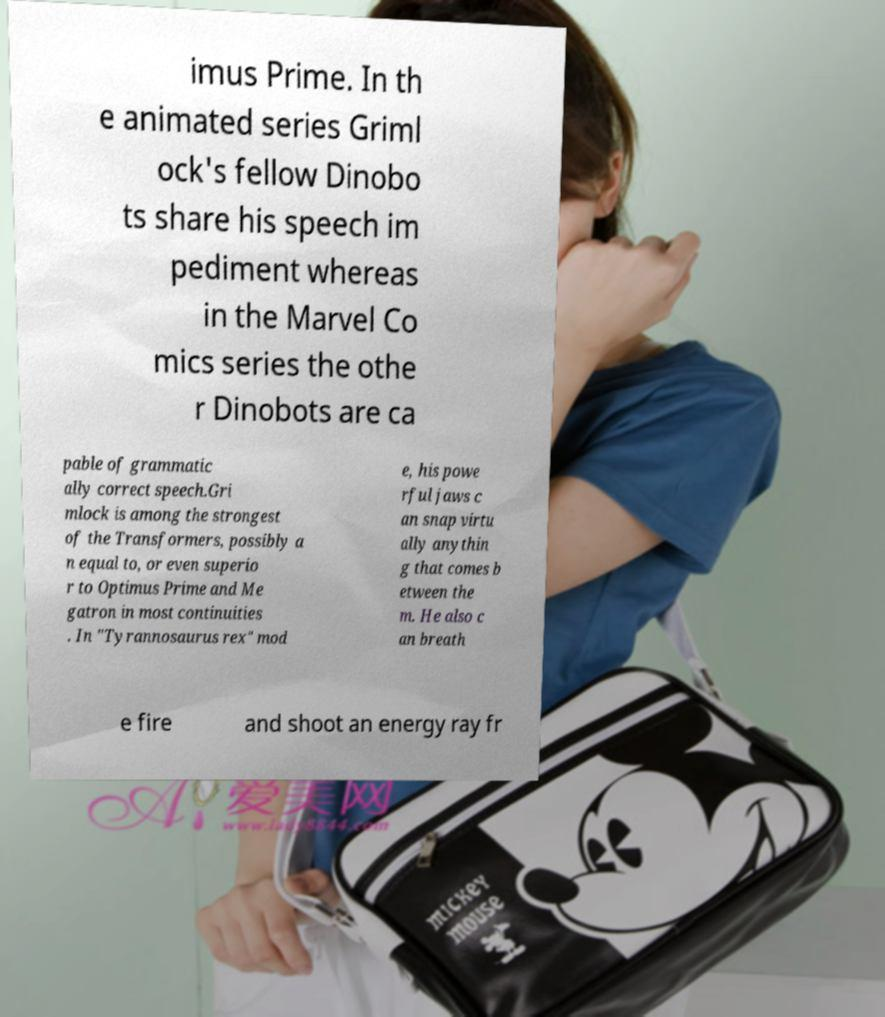Please identify and transcribe the text found in this image. imus Prime. In th e animated series Griml ock's fellow Dinobo ts share his speech im pediment whereas in the Marvel Co mics series the othe r Dinobots are ca pable of grammatic ally correct speech.Gri mlock is among the strongest of the Transformers, possibly a n equal to, or even superio r to Optimus Prime and Me gatron in most continuities . In "Tyrannosaurus rex" mod e, his powe rful jaws c an snap virtu ally anythin g that comes b etween the m. He also c an breath e fire and shoot an energy ray fr 